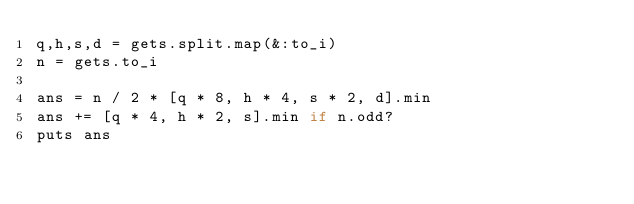<code> <loc_0><loc_0><loc_500><loc_500><_Ruby_>q,h,s,d = gets.split.map(&:to_i)
n = gets.to_i

ans = n / 2 * [q * 8, h * 4, s * 2, d].min
ans += [q * 4, h * 2, s].min if n.odd?
puts ans</code> 